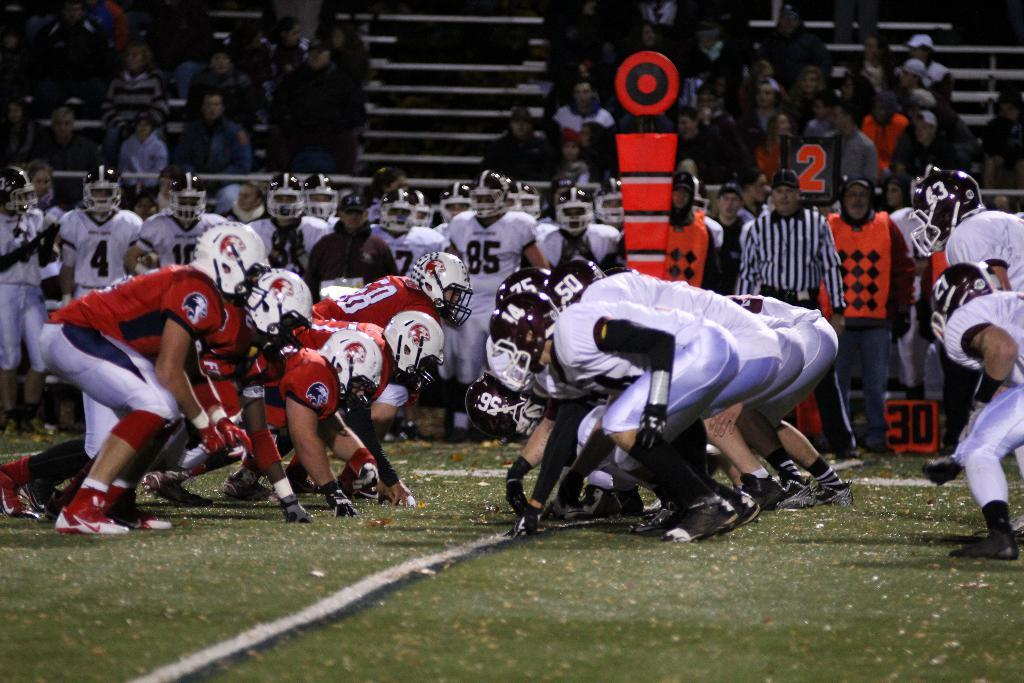What are the people in the foreground of the image doing? There is a group of people on the ground in the image. What are the people wearing on their heads? The people are wearing helmets. Can you describe the people in the background of the image? There is a group of people in the background of the image. What else can be seen in the background of the image? There are objects visible in the background of the image. What type of feeling can be seen on the faces of the ants in the image? There are no ants present in the image, so it is not possible to determine their feelings. 